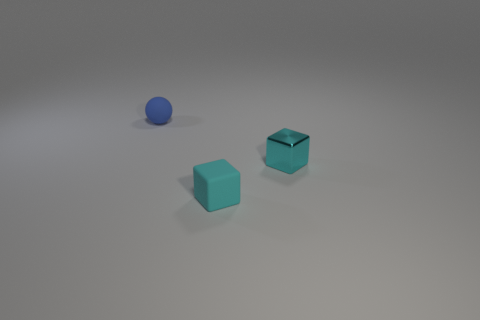Are there any objects of the same color as the matte cube? Yes, the other cube in the image has the same matte turquoise color as the first cube you mentioned. Both of these cubes share the same visual texture and color intensity, which stands out against the differently colored sphere and the neutral background. 